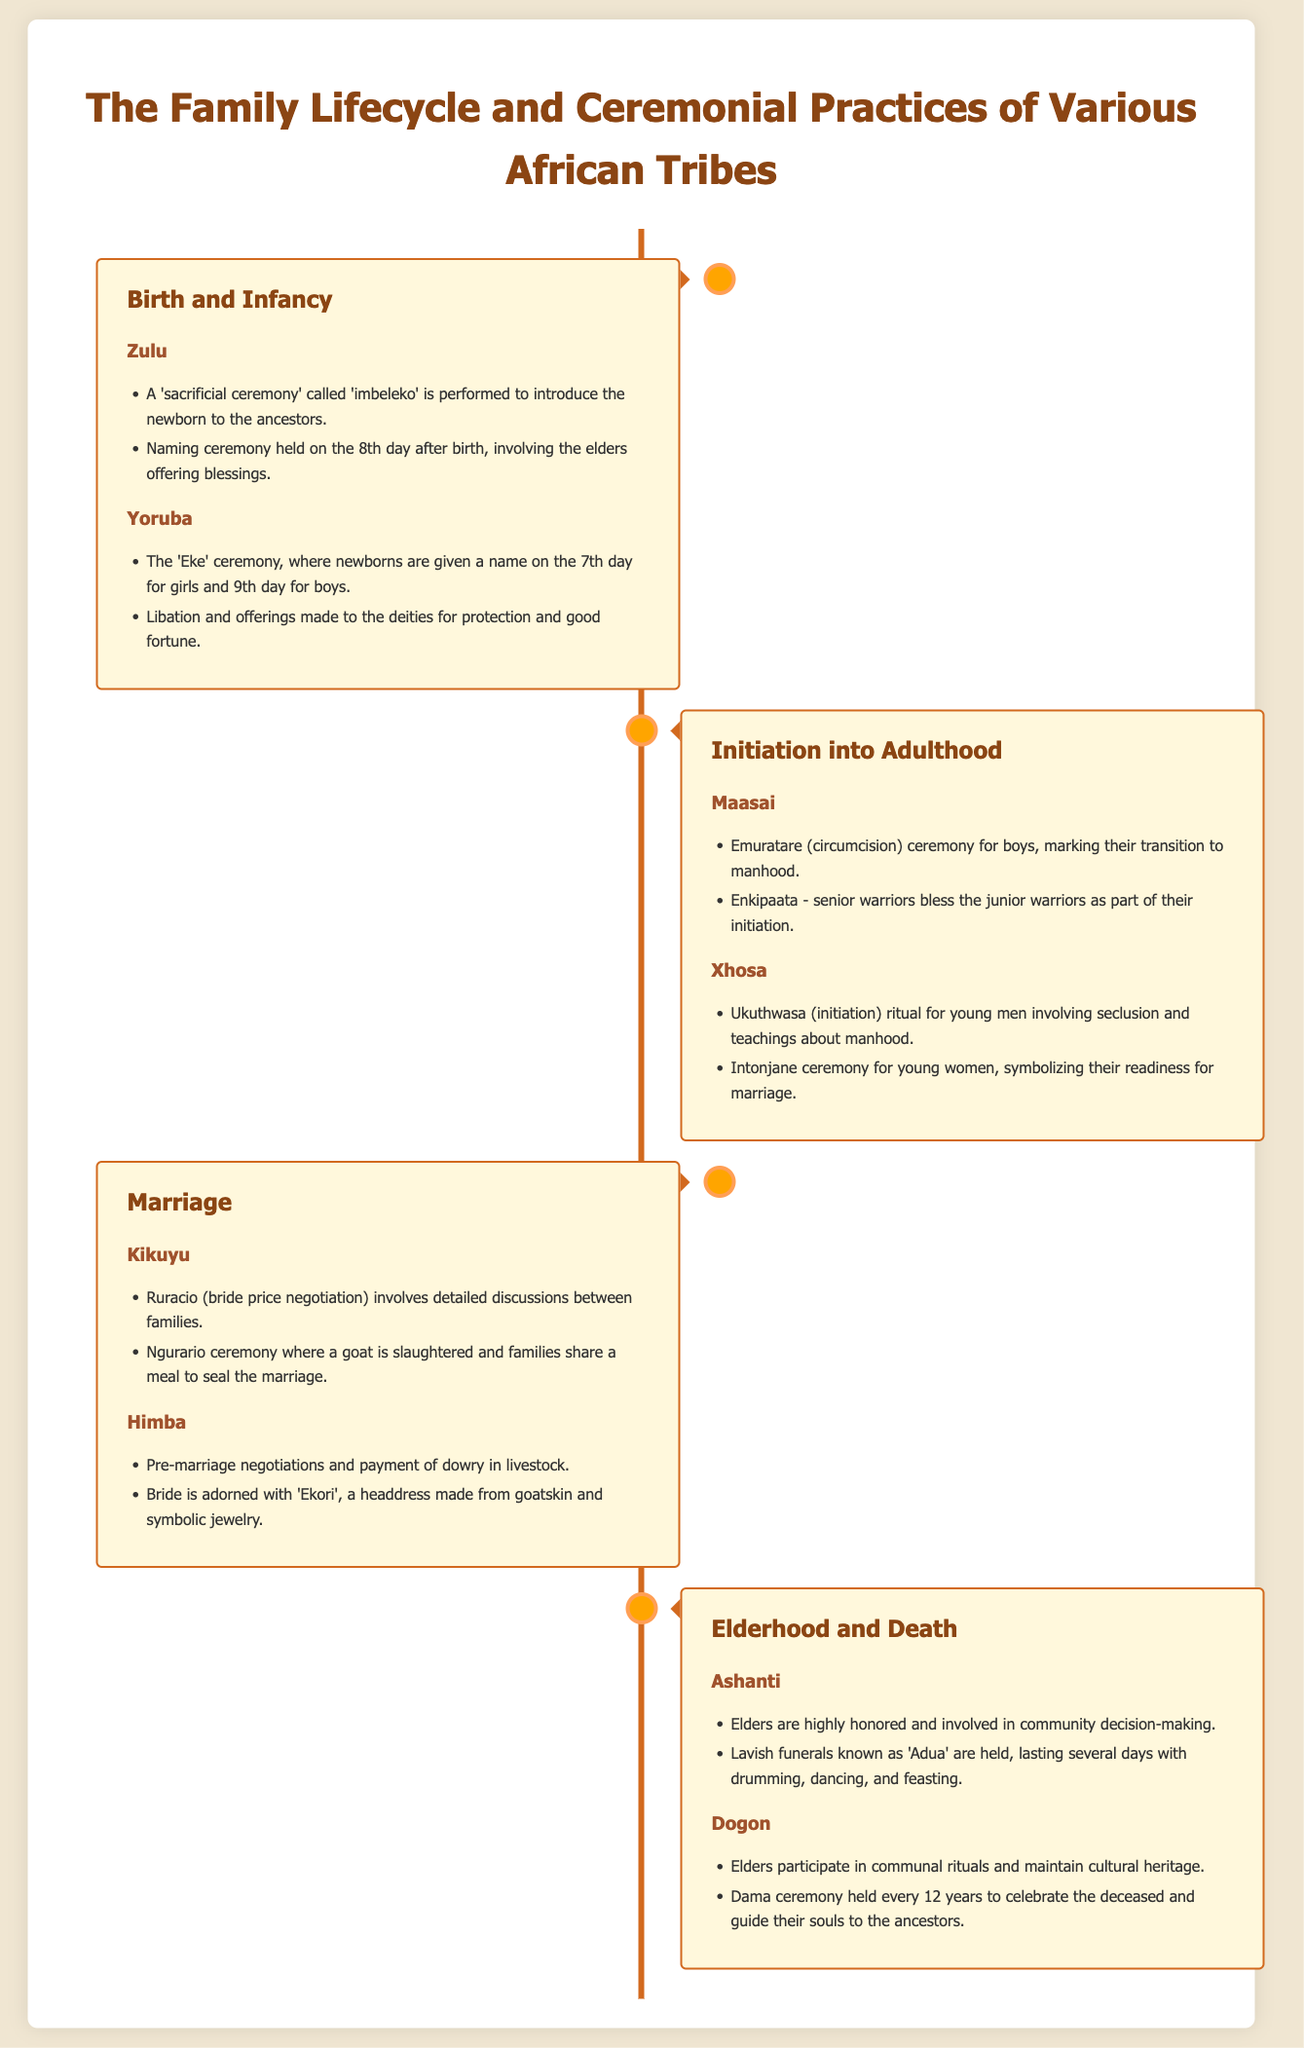What ceremony is performed for newborns in the Zulu tribe? The Zulu tribe performs a 'sacrificial ceremony' called 'imbeleko' to introduce the newborn to the ancestors.
Answer: imbeleko On which day is the Yoruba naming ceremony held for girls? The Yoruba naming ceremony for girls is held on the 7th day after birth.
Answer: 7th What is the Maasai ceremony for boys called? The Maasai ceremony for boys is called Emuratare, marking their transition to manhood.
Answer: Emuratare Which tribe conducts the Intonjane ceremony? The Intonjane ceremony is conducted by the Xhosa tribe for young women.
Answer: Xhosa What do Kikuyu families negotiate during Ruracio? During Ruracio, Kikuyu families negotiate the bride price.
Answer: bride price How often is the Dama ceremony held among the Dogon? The Dama ceremony is held every 12 years among the Dogon.
Answer: 12 years In which community are elders involved in decision-making? Elders are highly honored and involved in decision-making in the Ashanti community.
Answer: Ashanti What animal is slaughtered during the Ngurario ceremony? A goat is slaughtered during the Ngurario ceremony.
Answer: goat What symbol does the Himba bride wear? The Himba bride wears an 'Ekori', a headdress made from goatskin.
Answer: Ekori 